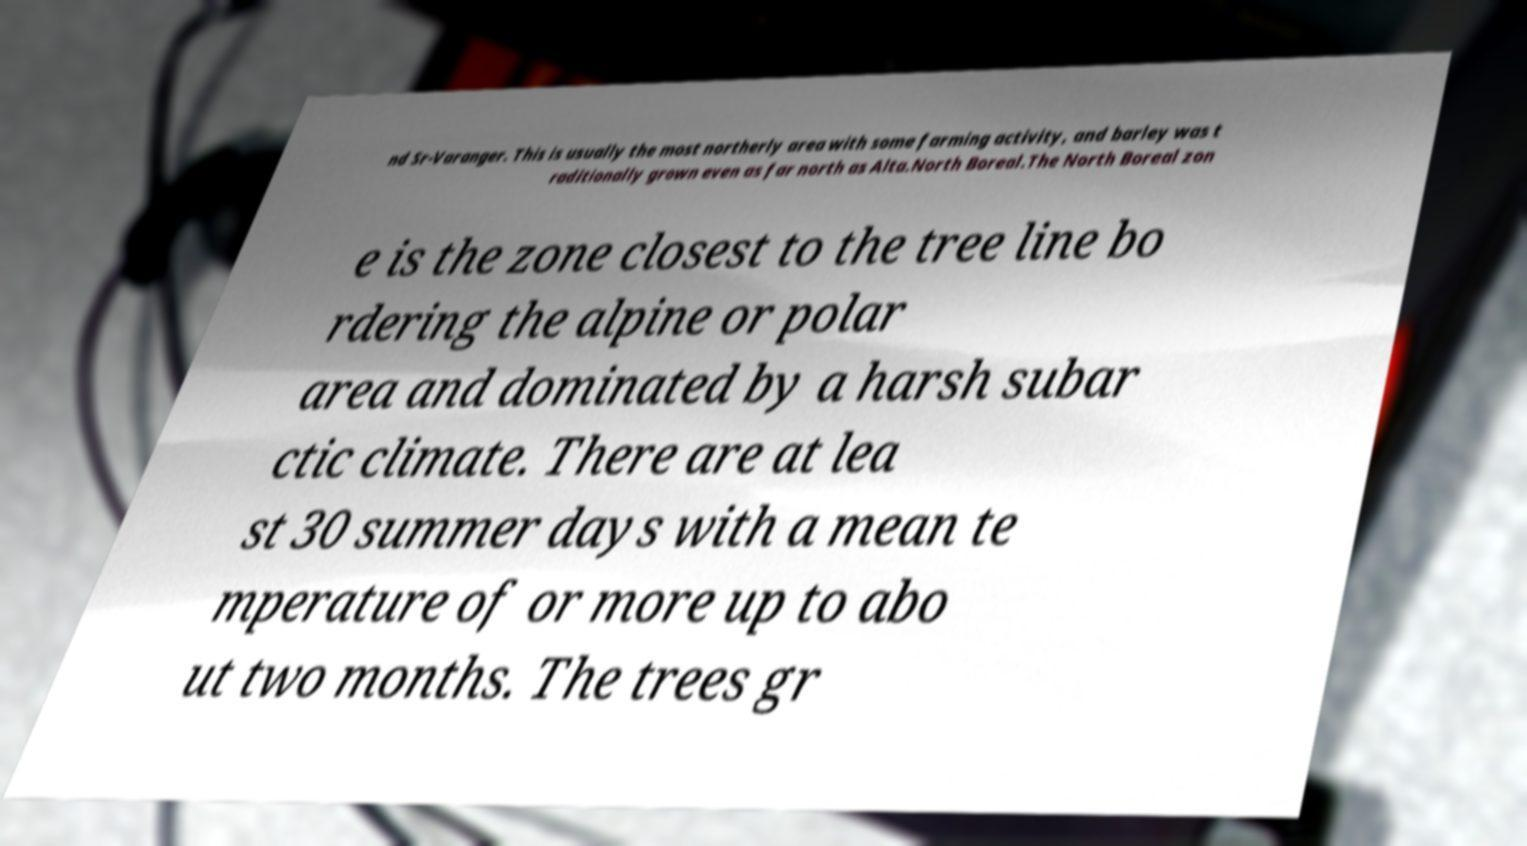I need the written content from this picture converted into text. Can you do that? nd Sr-Varanger. This is usually the most northerly area with some farming activity, and barley was t raditionally grown even as far north as Alta.North Boreal.The North Boreal zon e is the zone closest to the tree line bo rdering the alpine or polar area and dominated by a harsh subar ctic climate. There are at lea st 30 summer days with a mean te mperature of or more up to abo ut two months. The trees gr 